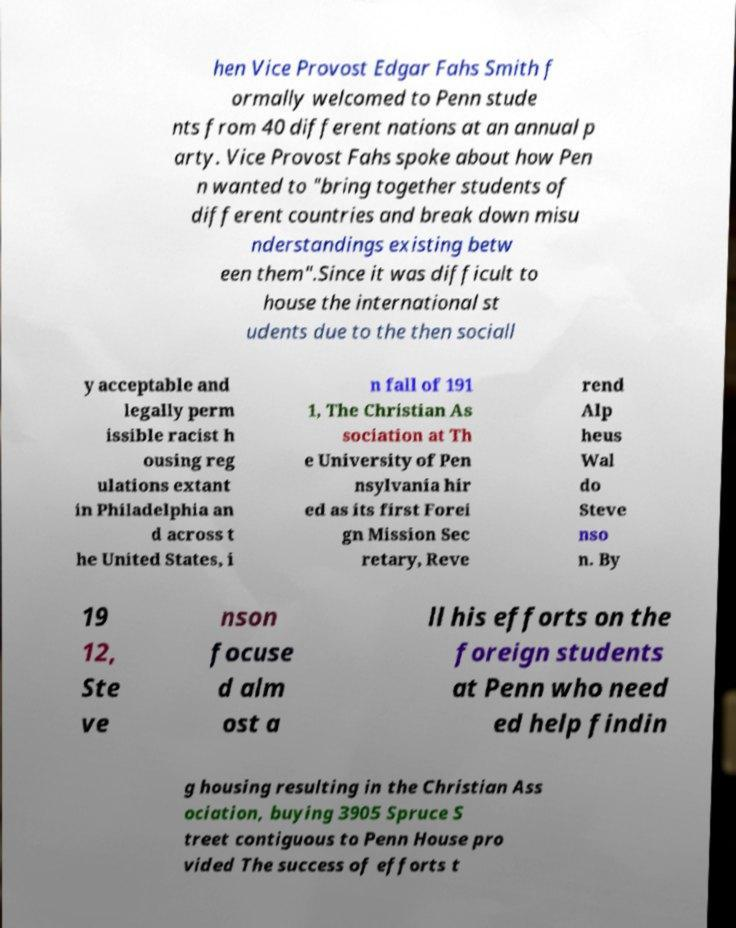Please read and relay the text visible in this image. What does it say? hen Vice Provost Edgar Fahs Smith f ormally welcomed to Penn stude nts from 40 different nations at an annual p arty. Vice Provost Fahs spoke about how Pen n wanted to "bring together students of different countries and break down misu nderstandings existing betw een them".Since it was difficult to house the international st udents due to the then sociall y acceptable and legally perm issible racist h ousing reg ulations extant in Philadelphia an d across t he United States, i n fall of 191 1, The Christian As sociation at Th e University of Pen nsylvania hir ed as its first Forei gn Mission Sec retary, Reve rend Alp heus Wal do Steve nso n. By 19 12, Ste ve nson focuse d alm ost a ll his efforts on the foreign students at Penn who need ed help findin g housing resulting in the Christian Ass ociation, buying 3905 Spruce S treet contiguous to Penn House pro vided The success of efforts t 